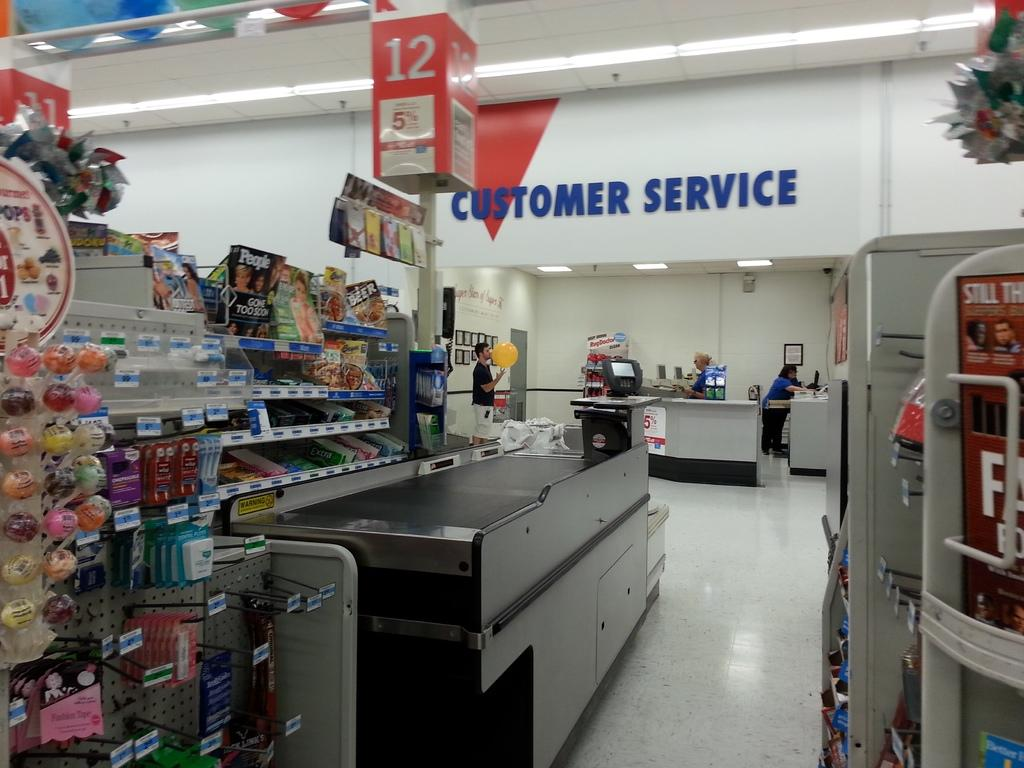<image>
Give a short and clear explanation of the subsequent image. a store cashier line in front of the Customer Service area with the number 12 